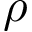Convert formula to latex. <formula><loc_0><loc_0><loc_500><loc_500>\rho</formula> 